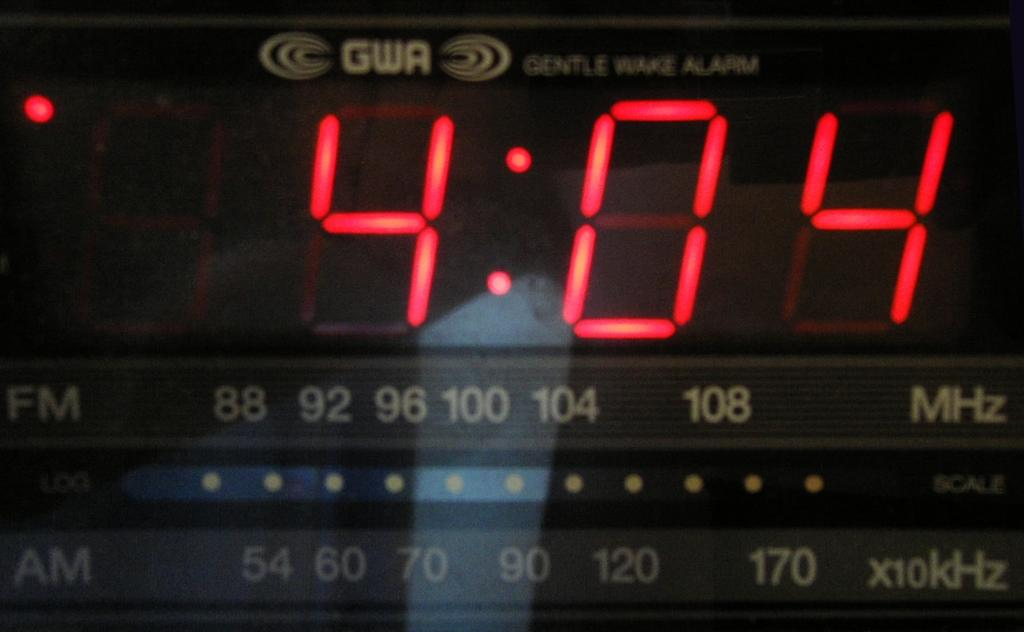Provide a one-sentence caption for the provided image. The GWA alarm clock show that the time is 4:04. 